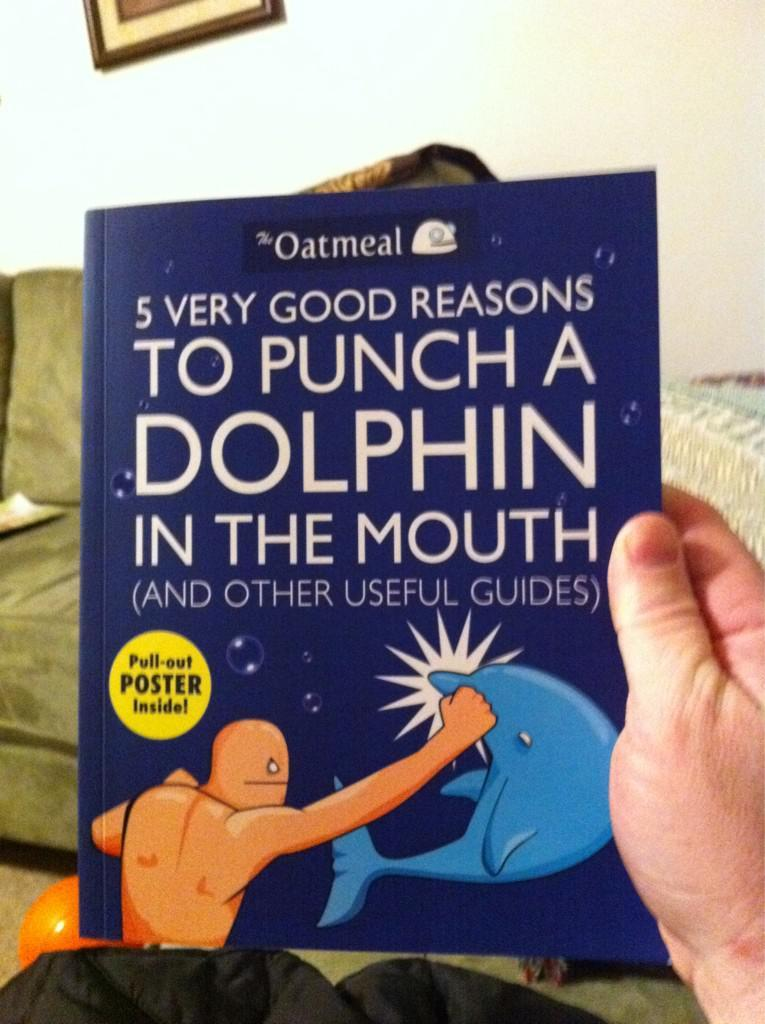<image>
Create a compact narrative representing the image presented. Someone is holding a book that has a pull-out poster inside. 